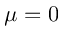Convert formula to latex. <formula><loc_0><loc_0><loc_500><loc_500>\mu = 0</formula> 